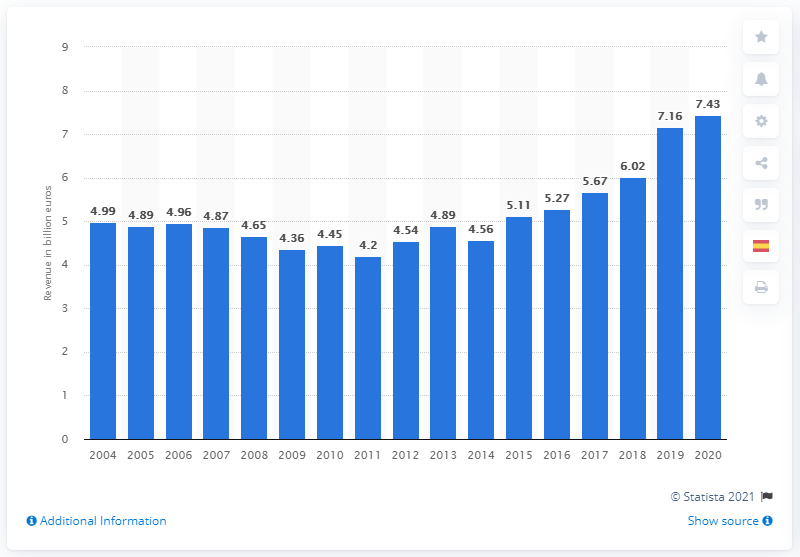Specify some key components in this picture. In 2020, Universal Music Group generated approximately 7.43 billion in revenue. 